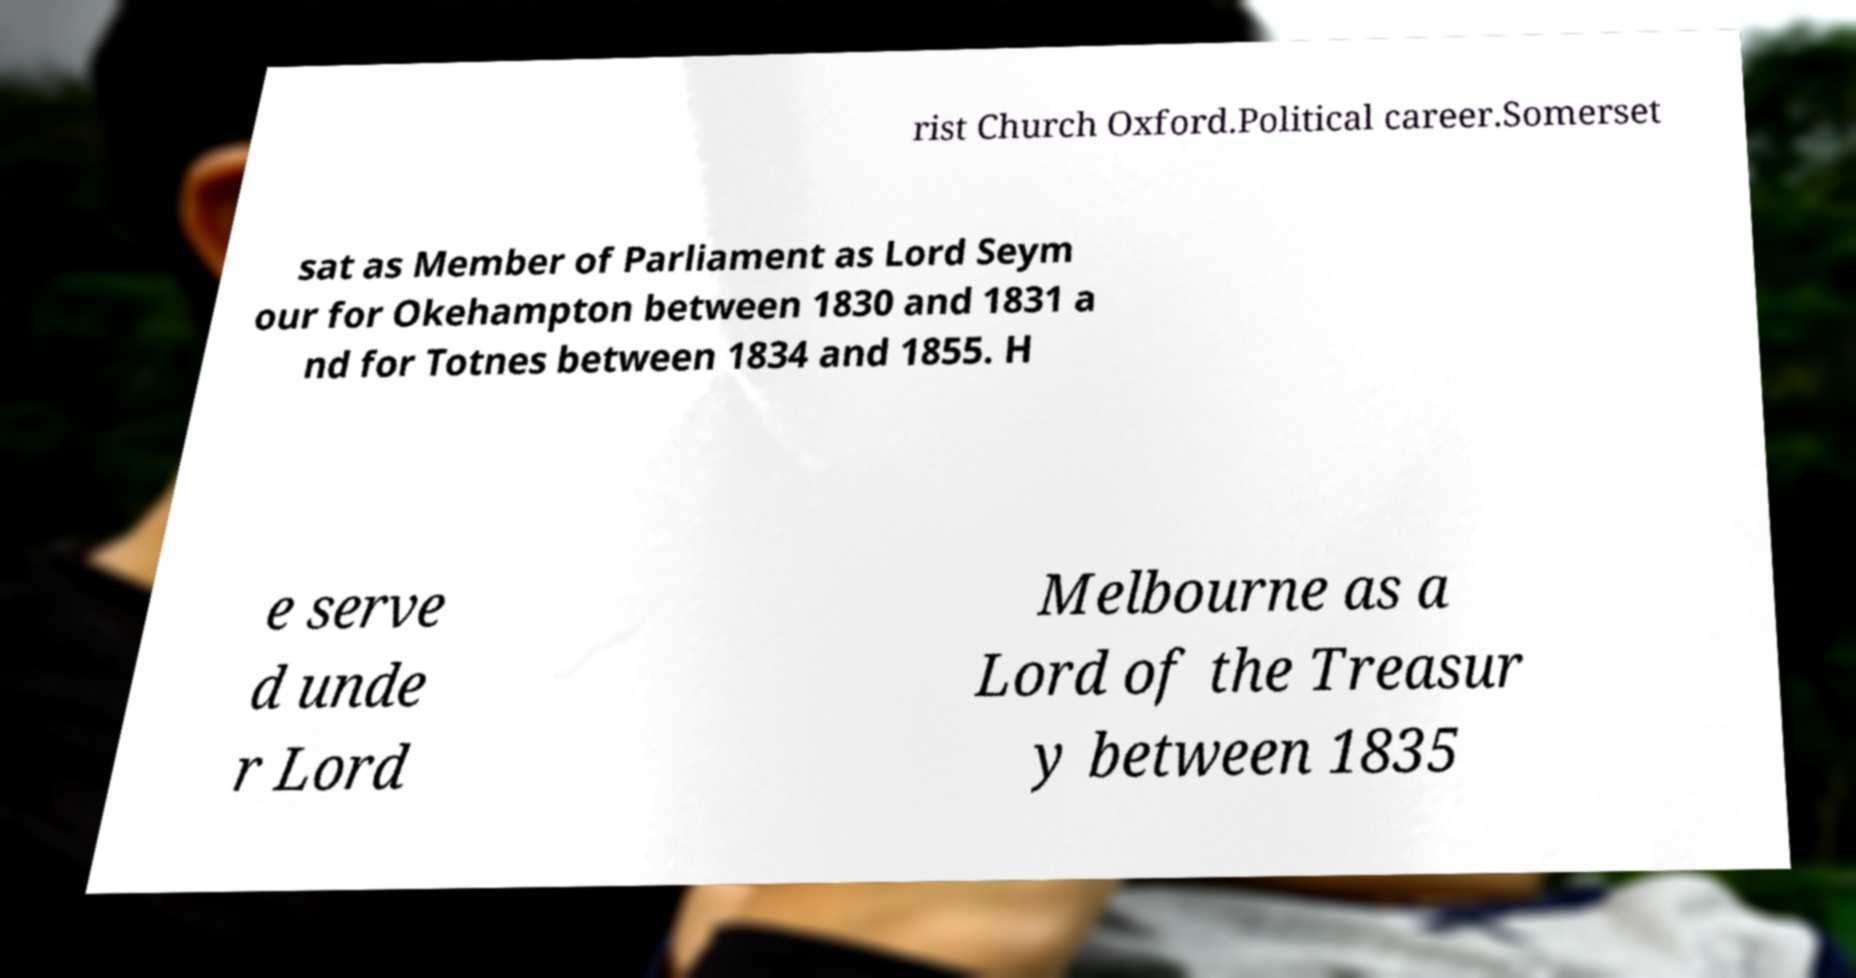Could you assist in decoding the text presented in this image and type it out clearly? rist Church Oxford.Political career.Somerset sat as Member of Parliament as Lord Seym our for Okehampton between 1830 and 1831 a nd for Totnes between 1834 and 1855. H e serve d unde r Lord Melbourne as a Lord of the Treasur y between 1835 